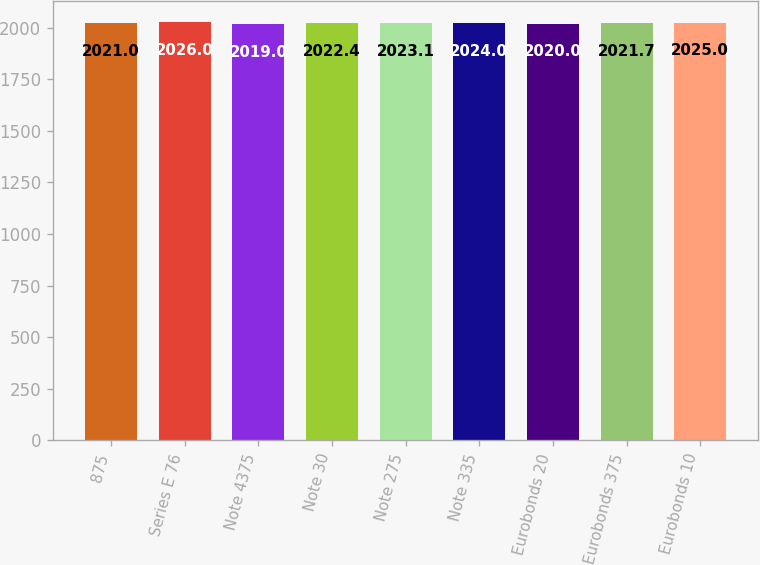Convert chart to OTSL. <chart><loc_0><loc_0><loc_500><loc_500><bar_chart><fcel>875<fcel>Series E 76<fcel>Note 4375<fcel>Note 30<fcel>Note 275<fcel>Note 335<fcel>Eurobonds 20<fcel>Eurobonds 375<fcel>Eurobonds 10<nl><fcel>2021<fcel>2026<fcel>2019<fcel>2022.4<fcel>2023.1<fcel>2024<fcel>2020<fcel>2021.7<fcel>2025<nl></chart> 